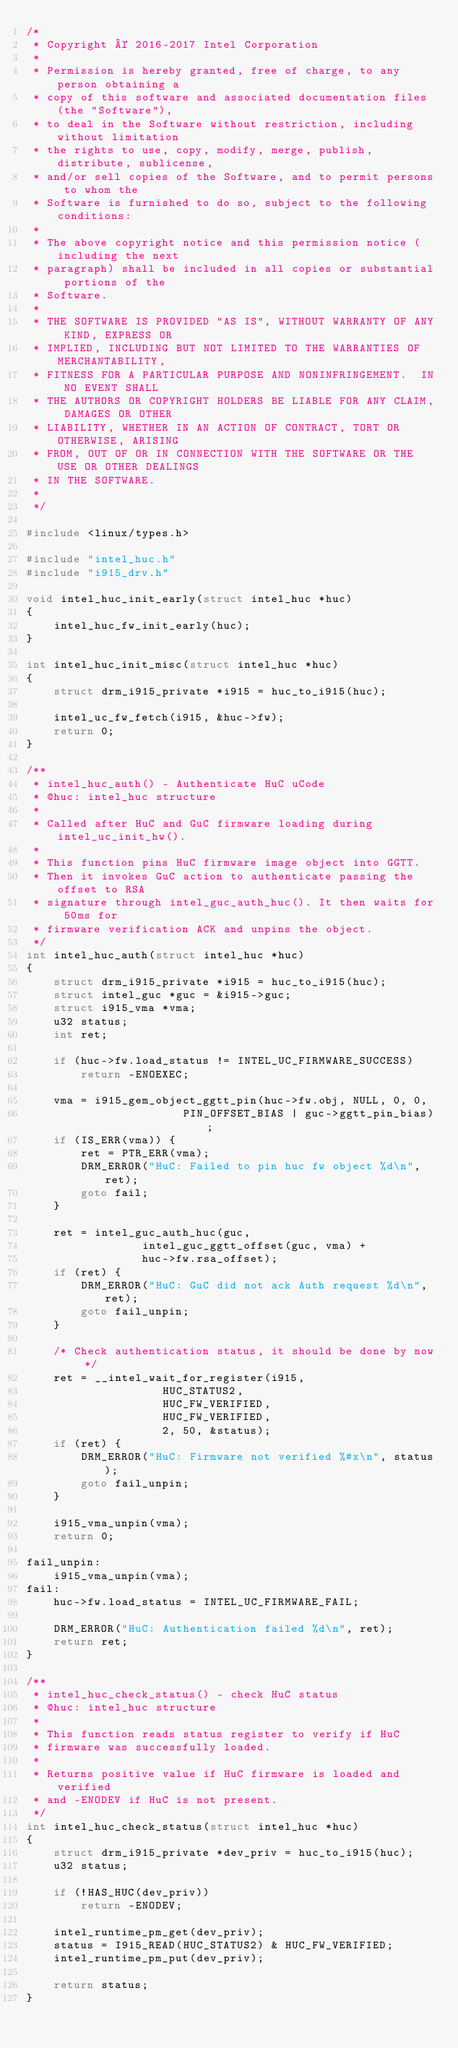Convert code to text. <code><loc_0><loc_0><loc_500><loc_500><_C_>/*
 * Copyright © 2016-2017 Intel Corporation
 *
 * Permission is hereby granted, free of charge, to any person obtaining a
 * copy of this software and associated documentation files (the "Software"),
 * to deal in the Software without restriction, including without limitation
 * the rights to use, copy, modify, merge, publish, distribute, sublicense,
 * and/or sell copies of the Software, and to permit persons to whom the
 * Software is furnished to do so, subject to the following conditions:
 *
 * The above copyright notice and this permission notice (including the next
 * paragraph) shall be included in all copies or substantial portions of the
 * Software.
 *
 * THE SOFTWARE IS PROVIDED "AS IS", WITHOUT WARRANTY OF ANY KIND, EXPRESS OR
 * IMPLIED, INCLUDING BUT NOT LIMITED TO THE WARRANTIES OF MERCHANTABILITY,
 * FITNESS FOR A PARTICULAR PURPOSE AND NONINFRINGEMENT.  IN NO EVENT SHALL
 * THE AUTHORS OR COPYRIGHT HOLDERS BE LIABLE FOR ANY CLAIM, DAMAGES OR OTHER
 * LIABILITY, WHETHER IN AN ACTION OF CONTRACT, TORT OR OTHERWISE, ARISING
 * FROM, OUT OF OR IN CONNECTION WITH THE SOFTWARE OR THE USE OR OTHER DEALINGS
 * IN THE SOFTWARE.
 *
 */

#include <linux/types.h>

#include "intel_huc.h"
#include "i915_drv.h"

void intel_huc_init_early(struct intel_huc *huc)
{
	intel_huc_fw_init_early(huc);
}

int intel_huc_init_misc(struct intel_huc *huc)
{
	struct drm_i915_private *i915 = huc_to_i915(huc);

	intel_uc_fw_fetch(i915, &huc->fw);
	return 0;
}

/**
 * intel_huc_auth() - Authenticate HuC uCode
 * @huc: intel_huc structure
 *
 * Called after HuC and GuC firmware loading during intel_uc_init_hw().
 *
 * This function pins HuC firmware image object into GGTT.
 * Then it invokes GuC action to authenticate passing the offset to RSA
 * signature through intel_guc_auth_huc(). It then waits for 50ms for
 * firmware verification ACK and unpins the object.
 */
int intel_huc_auth(struct intel_huc *huc)
{
	struct drm_i915_private *i915 = huc_to_i915(huc);
	struct intel_guc *guc = &i915->guc;
	struct i915_vma *vma;
	u32 status;
	int ret;

	if (huc->fw.load_status != INTEL_UC_FIRMWARE_SUCCESS)
		return -ENOEXEC;

	vma = i915_gem_object_ggtt_pin(huc->fw.obj, NULL, 0, 0,
				       PIN_OFFSET_BIAS | guc->ggtt_pin_bias);
	if (IS_ERR(vma)) {
		ret = PTR_ERR(vma);
		DRM_ERROR("HuC: Failed to pin huc fw object %d\n", ret);
		goto fail;
	}

	ret = intel_guc_auth_huc(guc,
				 intel_guc_ggtt_offset(guc, vma) +
				 huc->fw.rsa_offset);
	if (ret) {
		DRM_ERROR("HuC: GuC did not ack Auth request %d\n", ret);
		goto fail_unpin;
	}

	/* Check authentication status, it should be done by now */
	ret = __intel_wait_for_register(i915,
					HUC_STATUS2,
					HUC_FW_VERIFIED,
					HUC_FW_VERIFIED,
					2, 50, &status);
	if (ret) {
		DRM_ERROR("HuC: Firmware not verified %#x\n", status);
		goto fail_unpin;
	}

	i915_vma_unpin(vma);
	return 0;

fail_unpin:
	i915_vma_unpin(vma);
fail:
	huc->fw.load_status = INTEL_UC_FIRMWARE_FAIL;

	DRM_ERROR("HuC: Authentication failed %d\n", ret);
	return ret;
}

/**
 * intel_huc_check_status() - check HuC status
 * @huc: intel_huc structure
 *
 * This function reads status register to verify if HuC
 * firmware was successfully loaded.
 *
 * Returns positive value if HuC firmware is loaded and verified
 * and -ENODEV if HuC is not present.
 */
int intel_huc_check_status(struct intel_huc *huc)
{
	struct drm_i915_private *dev_priv = huc_to_i915(huc);
	u32 status;

	if (!HAS_HUC(dev_priv))
		return -ENODEV;

	intel_runtime_pm_get(dev_priv);
	status = I915_READ(HUC_STATUS2) & HUC_FW_VERIFIED;
	intel_runtime_pm_put(dev_priv);

	return status;
}
</code> 